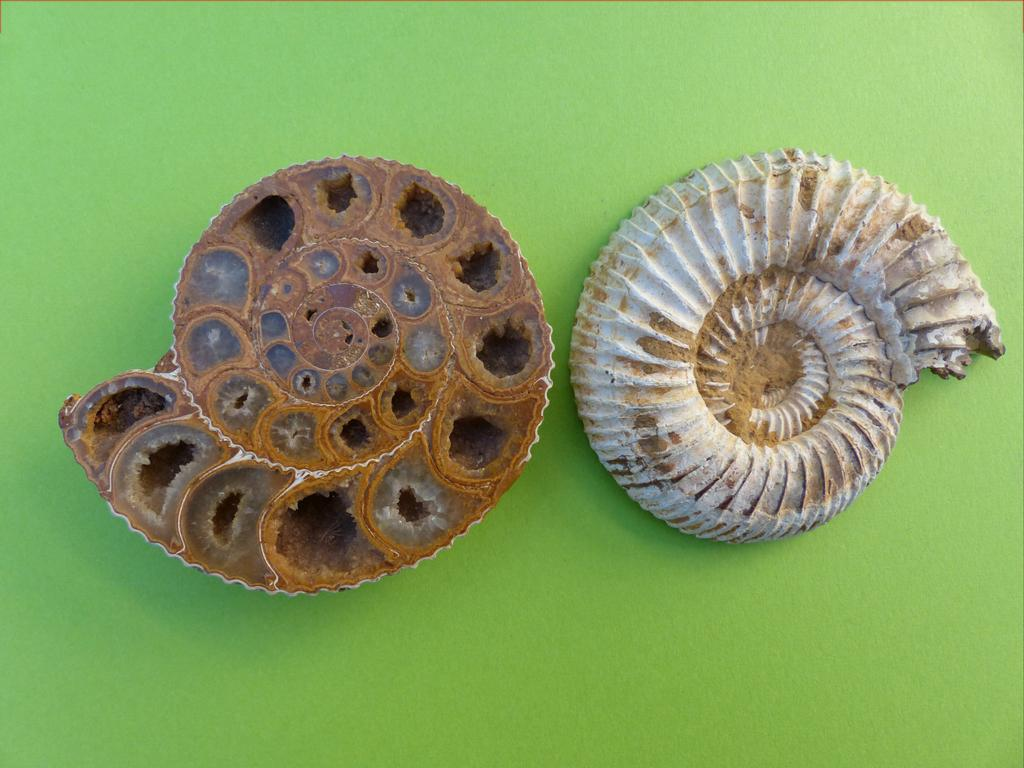What are the main subjects in the image? There are two Ammonites in the image. What color is the background of the image? The background of the image is green. How do the Ammonites say good-bye to each other in the image? The Ammonites are fossils and do not have the ability to say good-bye or communicate in any way. 